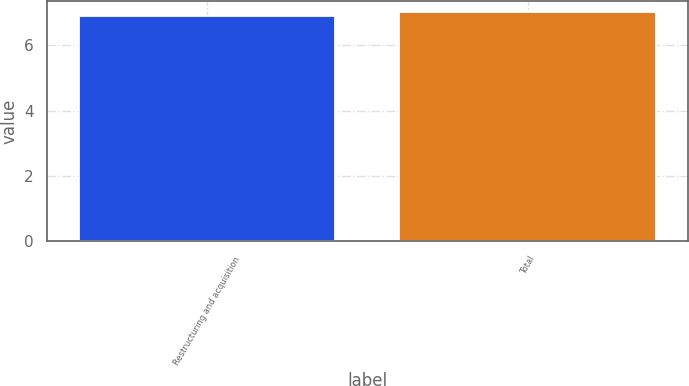Convert chart. <chart><loc_0><loc_0><loc_500><loc_500><bar_chart><fcel>Restructuring and acquisition<fcel>Total<nl><fcel>6.9<fcel>7<nl></chart> 